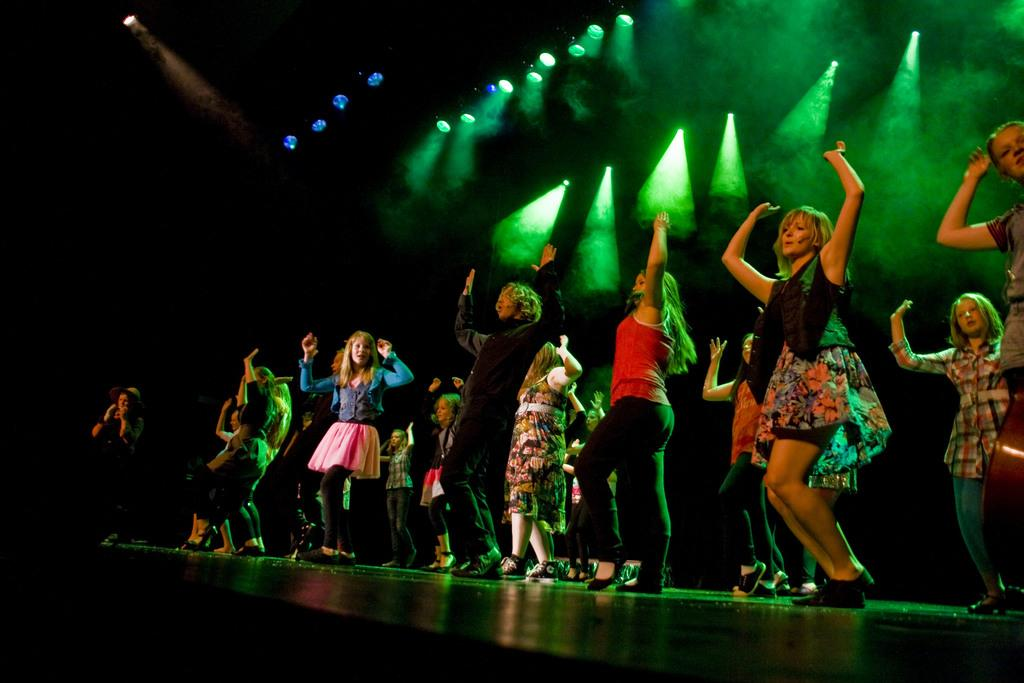What is happening in the center of the image? There are people in the center of the image. Where are the people located? The people are on a stage. What are the people doing on the stage? The people are dancing. What can be seen at the top side of the image? There are spotlights at the top side of the image. What is the acoustics like in the image? The provided facts do not give any information about the acoustics in the image, so it cannot be determined from the image. 